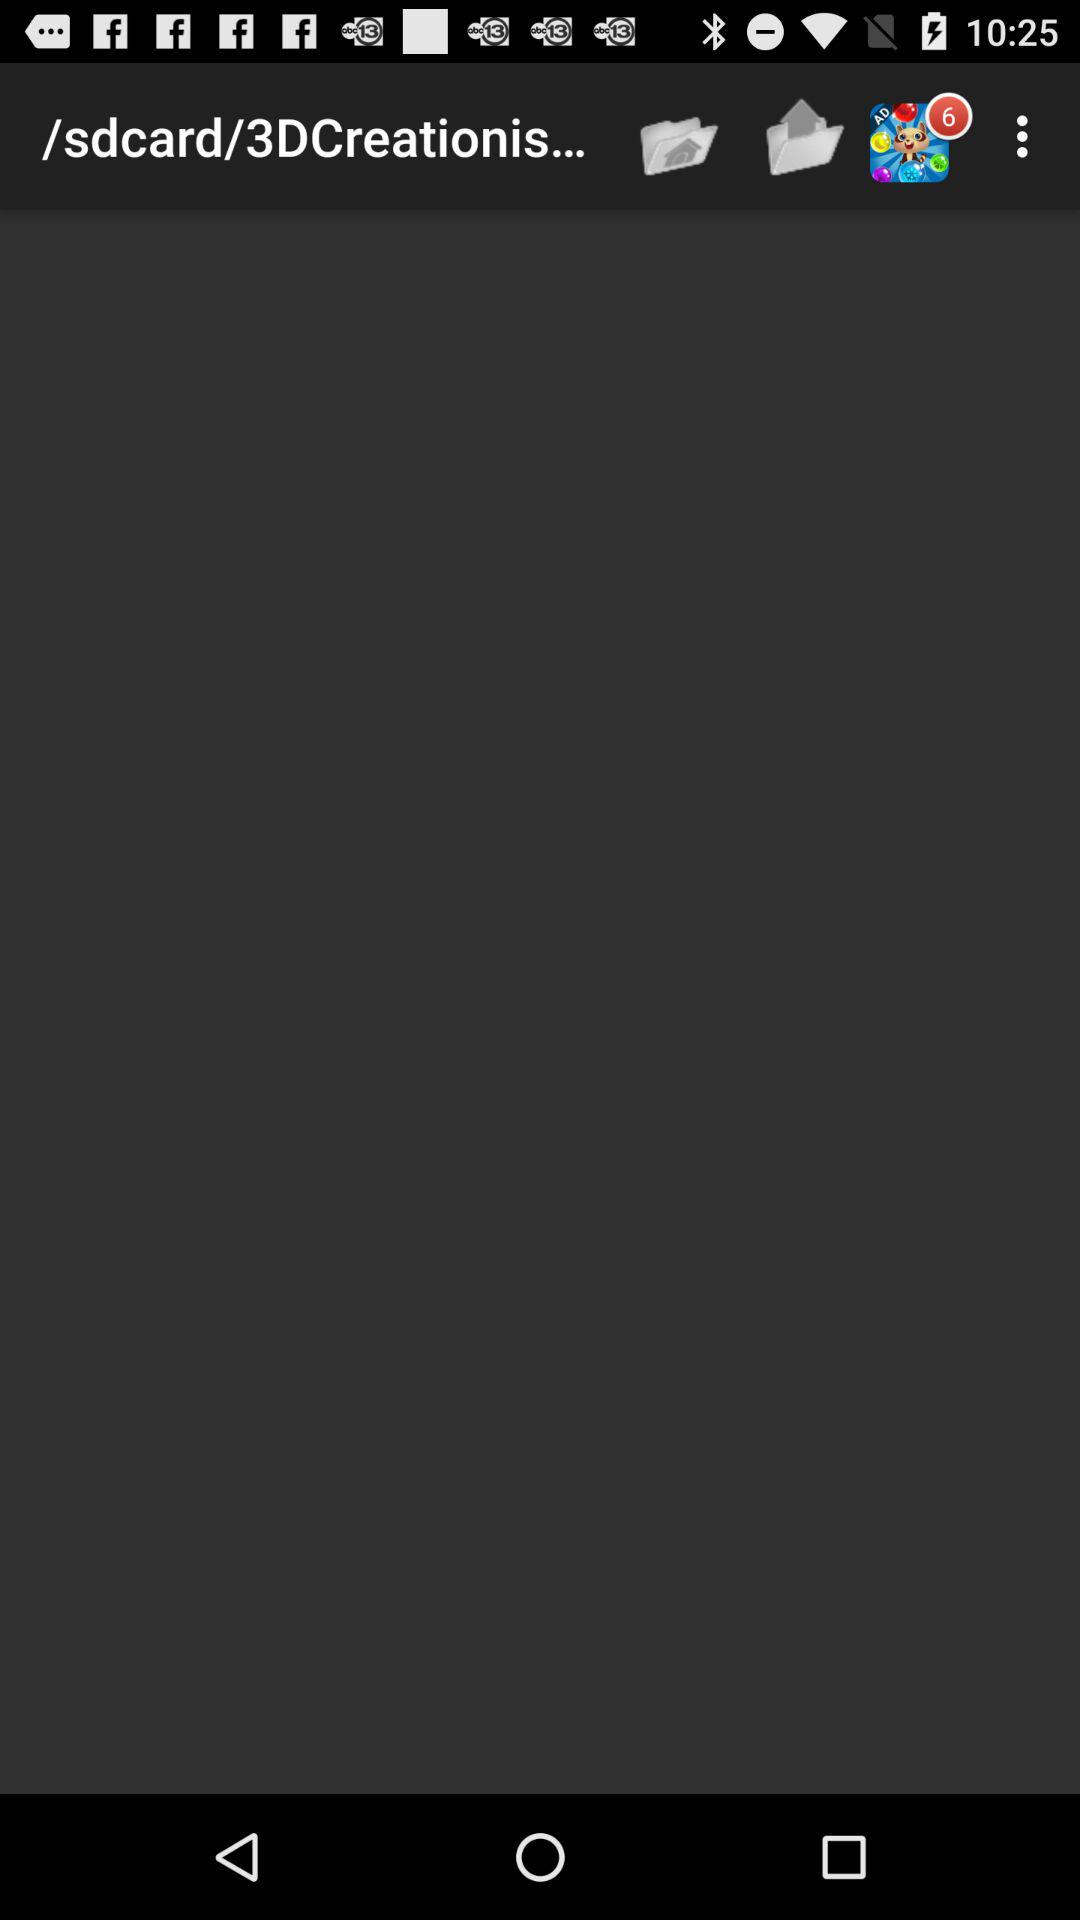How many notifications are currently in the queue for the advertisement? The number of notifications currently in the queue for the advertisement is 6. 